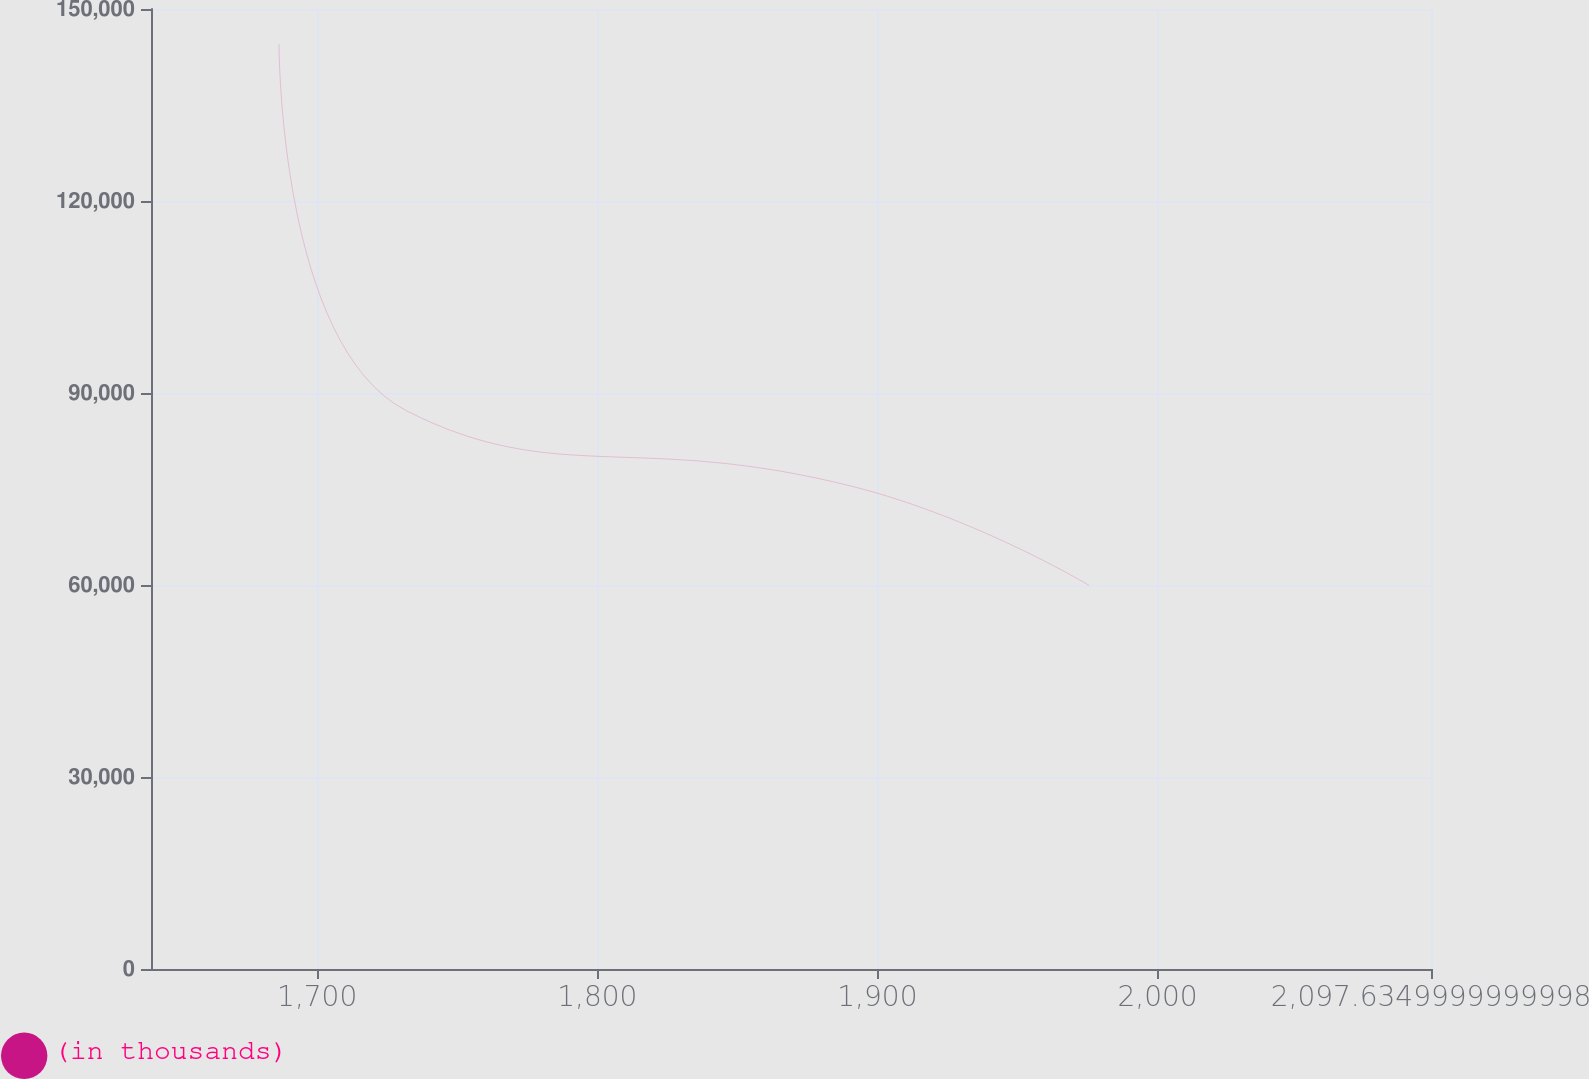Convert chart. <chart><loc_0><loc_0><loc_500><loc_500><line_chart><ecel><fcel>(in thousands)<nl><fcel>1686.38<fcel>144492<nl><fcel>1732.08<fcel>87182.3<nl><fcel>1892.01<fcel>75298.4<nl><fcel>1975.53<fcel>59956.4<nl><fcel>2143.33<fcel>28157.6<nl></chart> 